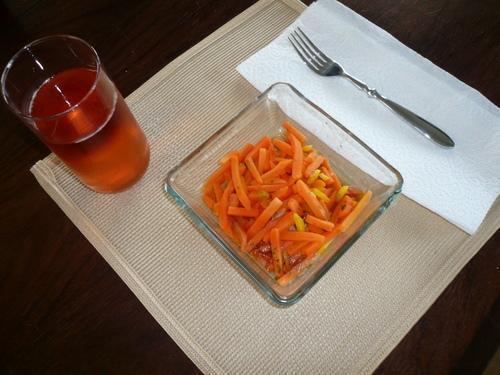How many different kinds of food are there?
Give a very brief answer. 1. How many carrots can be seen?
Give a very brief answer. 1. How many beds are in this room?
Give a very brief answer. 0. 